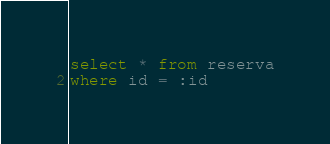Convert code to text. <code><loc_0><loc_0><loc_500><loc_500><_SQL_>select * from reserva
where id = :id</code> 